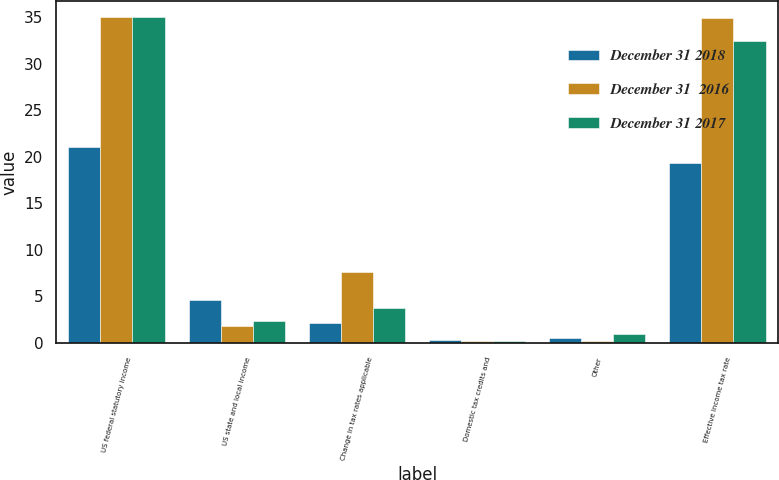<chart> <loc_0><loc_0><loc_500><loc_500><stacked_bar_chart><ecel><fcel>US federal statutory income<fcel>US state and local income<fcel>Change in tax rates applicable<fcel>Domestic tax credits and<fcel>Other<fcel>Effective income tax rate<nl><fcel>December 31 2018<fcel>21<fcel>4.66<fcel>2.2<fcel>0.3<fcel>0.54<fcel>19.37<nl><fcel>December 31  2016<fcel>35<fcel>1.84<fcel>7.6<fcel>0.24<fcel>0.25<fcel>34.9<nl><fcel>December 31 2017<fcel>35<fcel>2.38<fcel>3.73<fcel>0.26<fcel>0.98<fcel>32.41<nl></chart> 